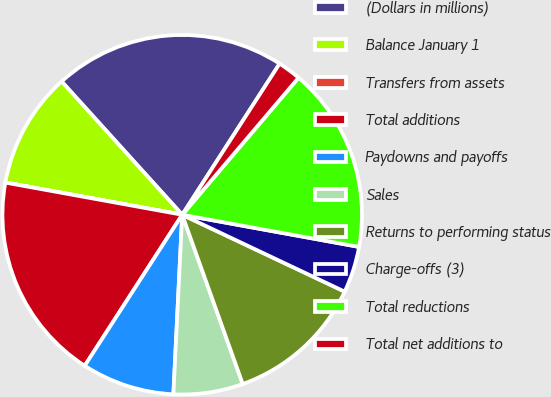Convert chart to OTSL. <chart><loc_0><loc_0><loc_500><loc_500><pie_chart><fcel>(Dollars in millions)<fcel>Balance January 1<fcel>Transfers from assets<fcel>Total additions<fcel>Paydowns and payoffs<fcel>Sales<fcel>Returns to performing status<fcel>Charge-offs (3)<fcel>Total reductions<fcel>Total net additions to<nl><fcel>20.82%<fcel>10.42%<fcel>0.01%<fcel>18.74%<fcel>8.34%<fcel>6.25%<fcel>12.5%<fcel>4.17%<fcel>16.66%<fcel>2.09%<nl></chart> 